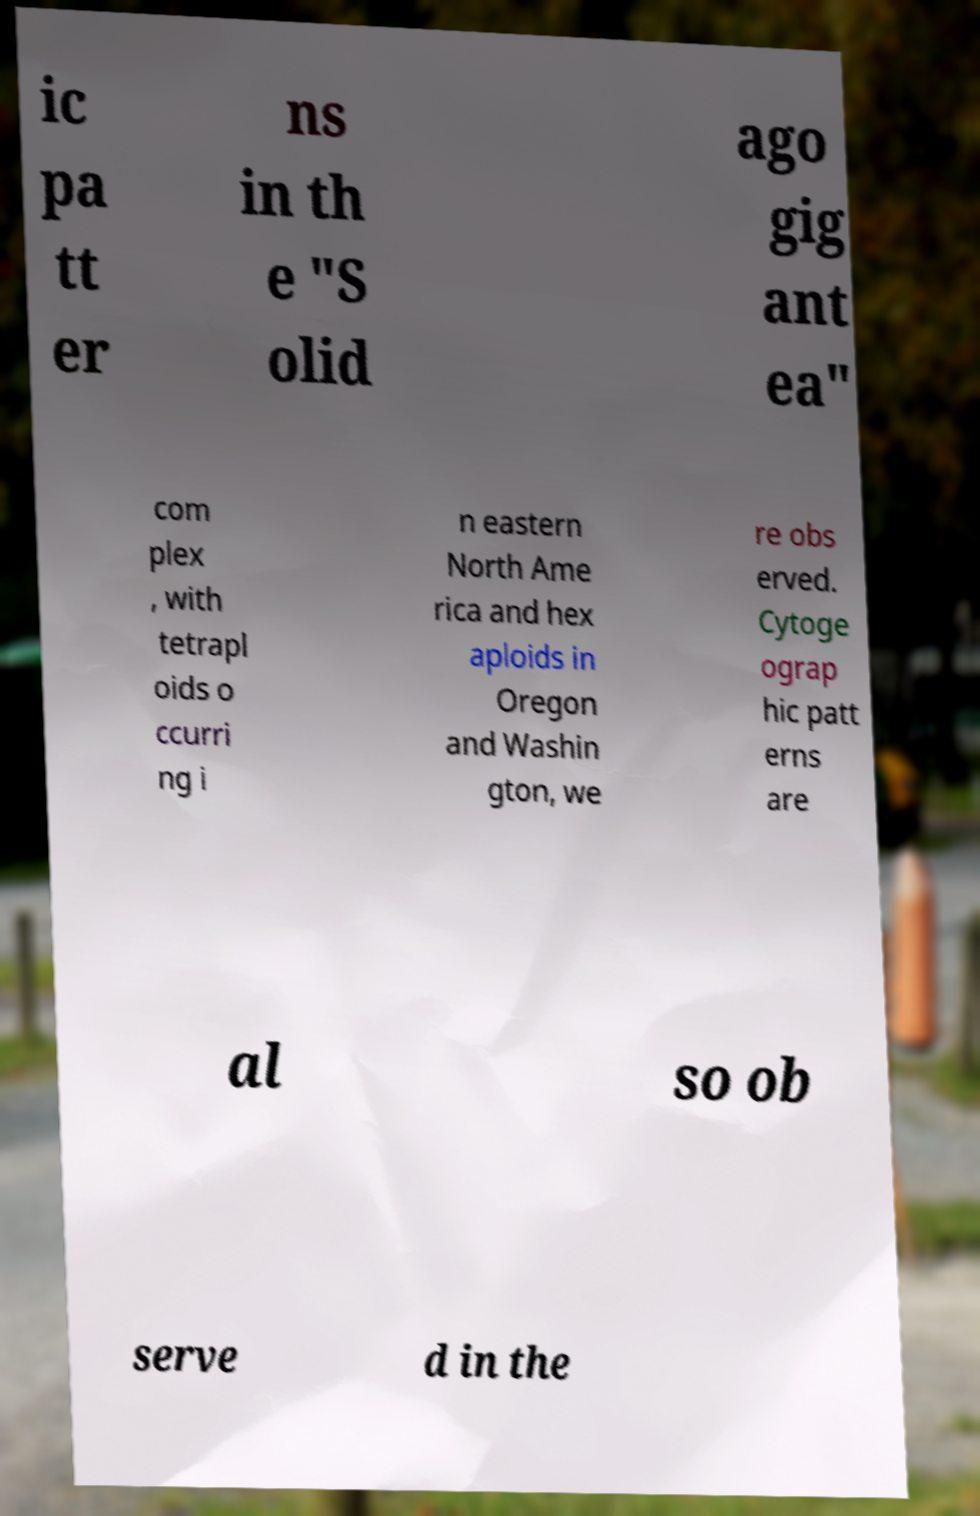For documentation purposes, I need the text within this image transcribed. Could you provide that? ic pa tt er ns in th e "S olid ago gig ant ea" com plex , with tetrapl oids o ccurri ng i n eastern North Ame rica and hex aploids in Oregon and Washin gton, we re obs erved. Cytoge ograp hic patt erns are al so ob serve d in the 